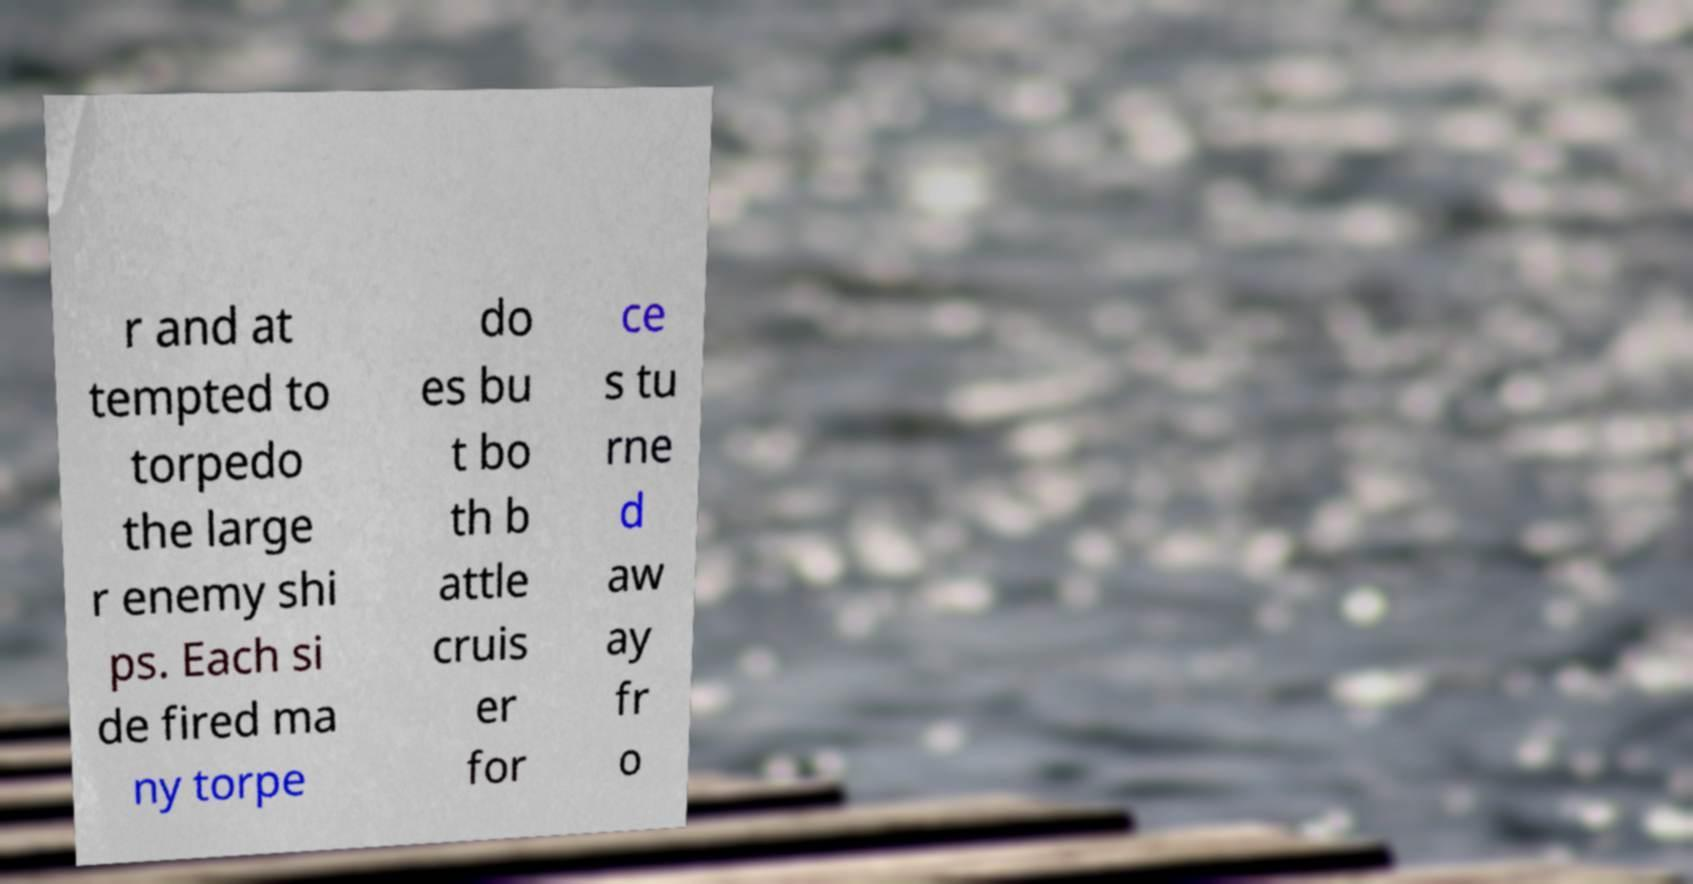There's text embedded in this image that I need extracted. Can you transcribe it verbatim? r and at tempted to torpedo the large r enemy shi ps. Each si de fired ma ny torpe do es bu t bo th b attle cruis er for ce s tu rne d aw ay fr o 